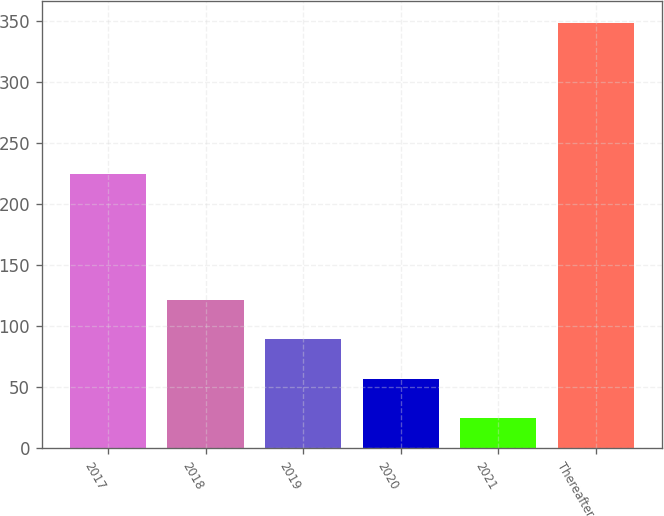Convert chart to OTSL. <chart><loc_0><loc_0><loc_500><loc_500><bar_chart><fcel>2017<fcel>2018<fcel>2019<fcel>2020<fcel>2021<fcel>Thereafter<nl><fcel>224<fcel>121.47<fcel>89.08<fcel>56.69<fcel>24.3<fcel>348.2<nl></chart> 